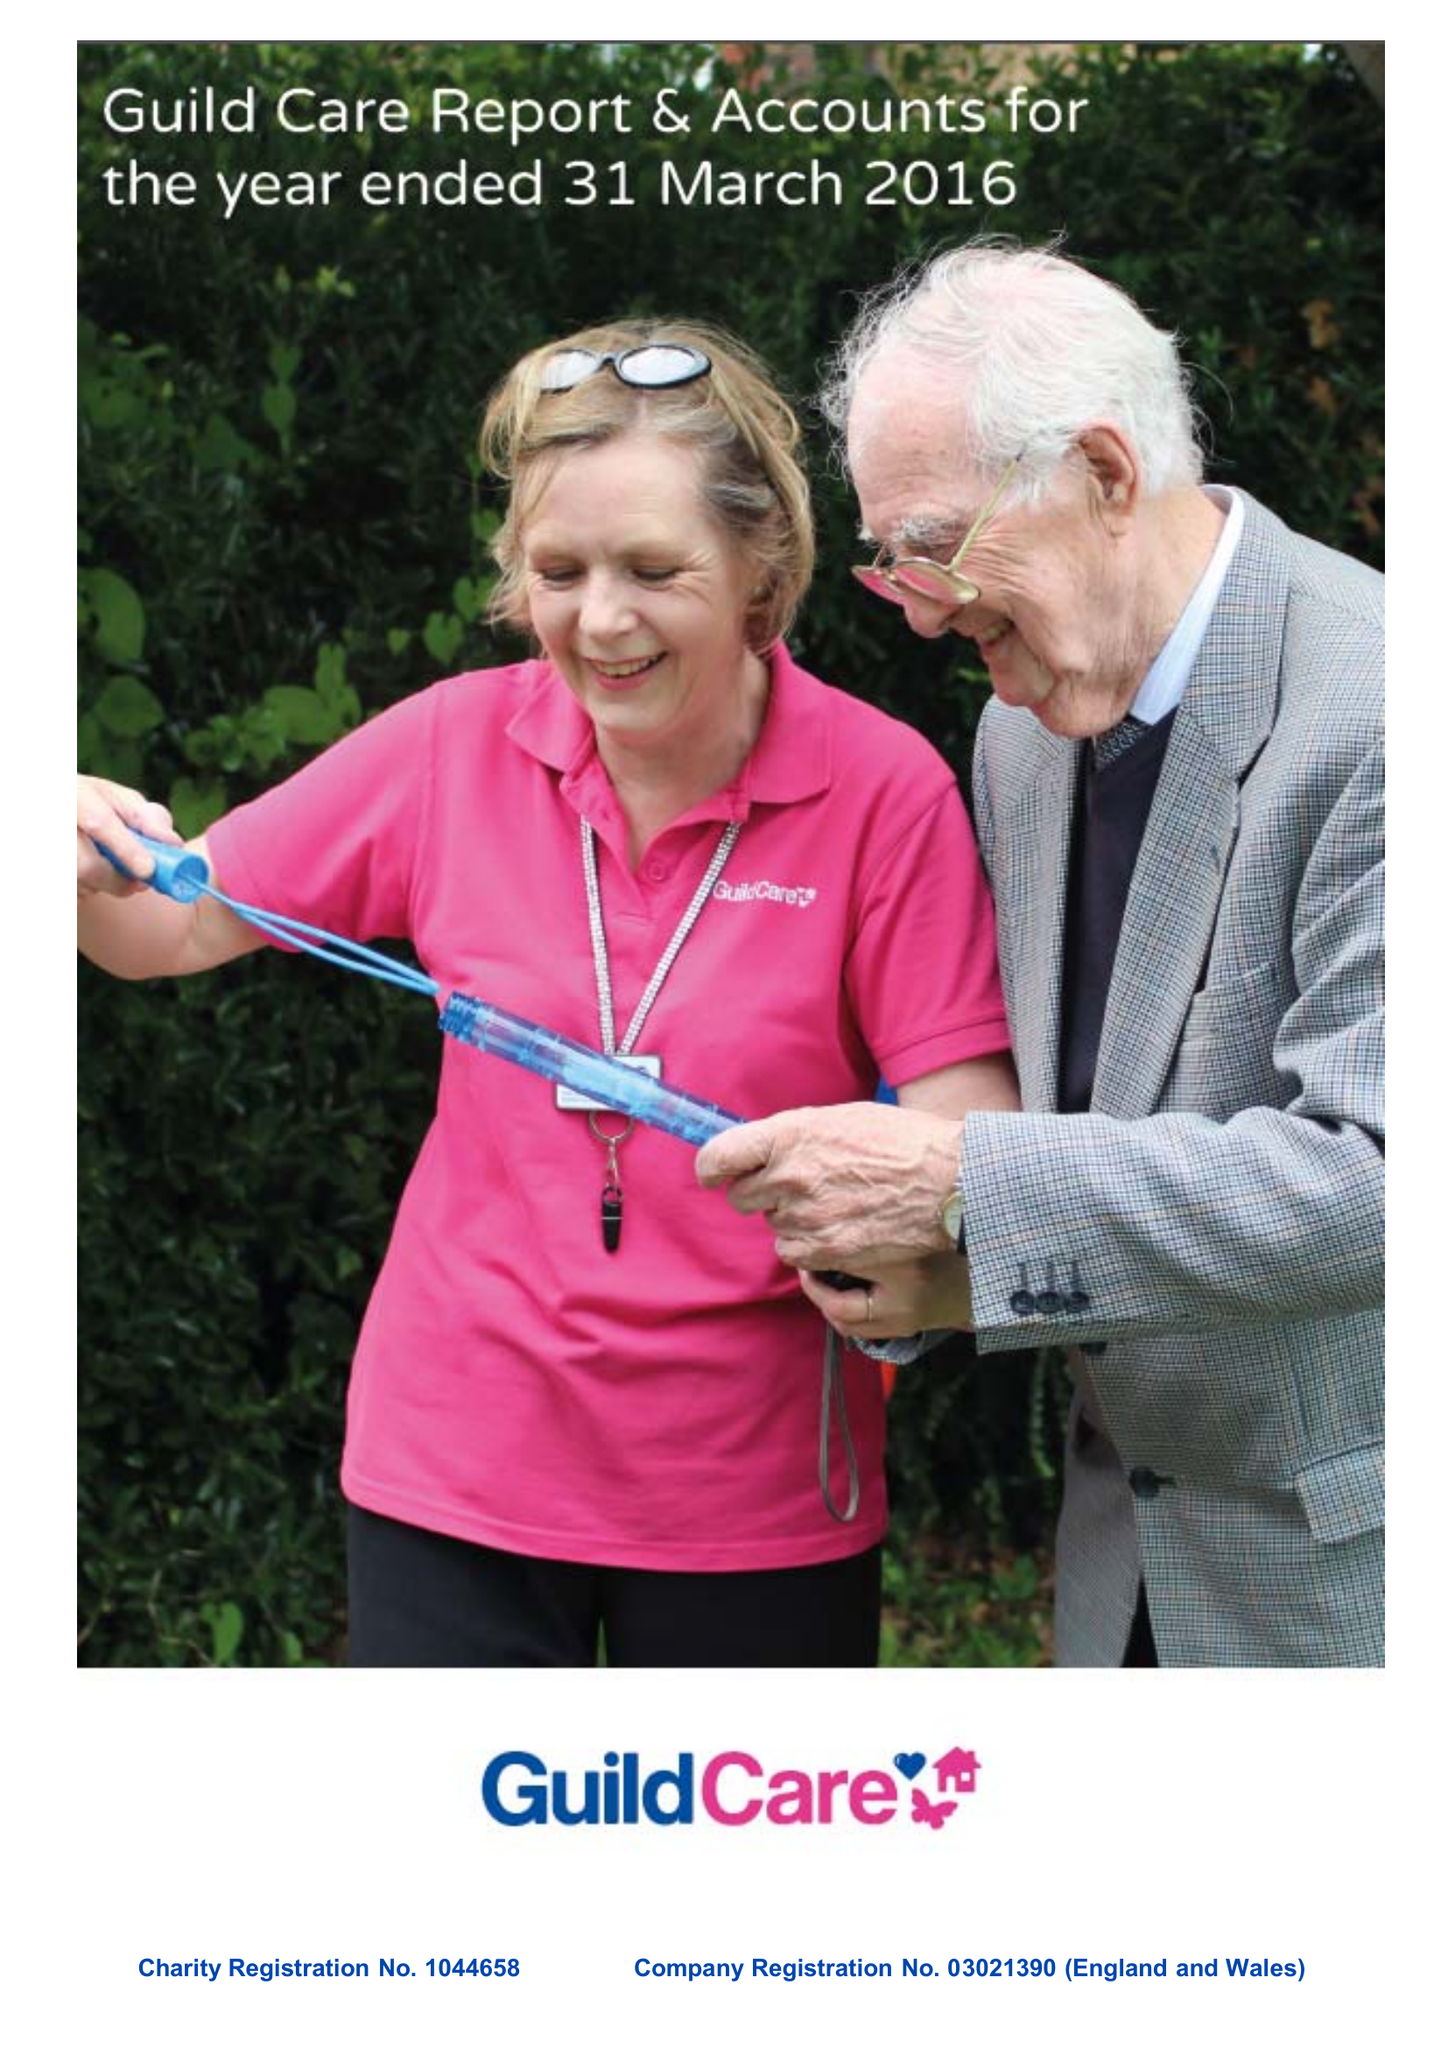What is the value for the address__post_town?
Answer the question using a single word or phrase. WORTHING 